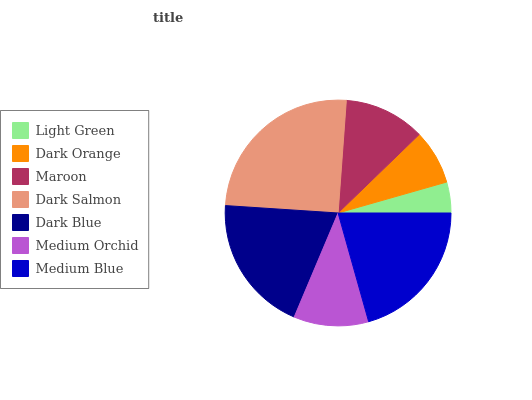Is Light Green the minimum?
Answer yes or no. Yes. Is Dark Salmon the maximum?
Answer yes or no. Yes. Is Dark Orange the minimum?
Answer yes or no. No. Is Dark Orange the maximum?
Answer yes or no. No. Is Dark Orange greater than Light Green?
Answer yes or no. Yes. Is Light Green less than Dark Orange?
Answer yes or no. Yes. Is Light Green greater than Dark Orange?
Answer yes or no. No. Is Dark Orange less than Light Green?
Answer yes or no. No. Is Maroon the high median?
Answer yes or no. Yes. Is Maroon the low median?
Answer yes or no. Yes. Is Medium Orchid the high median?
Answer yes or no. No. Is Light Green the low median?
Answer yes or no. No. 